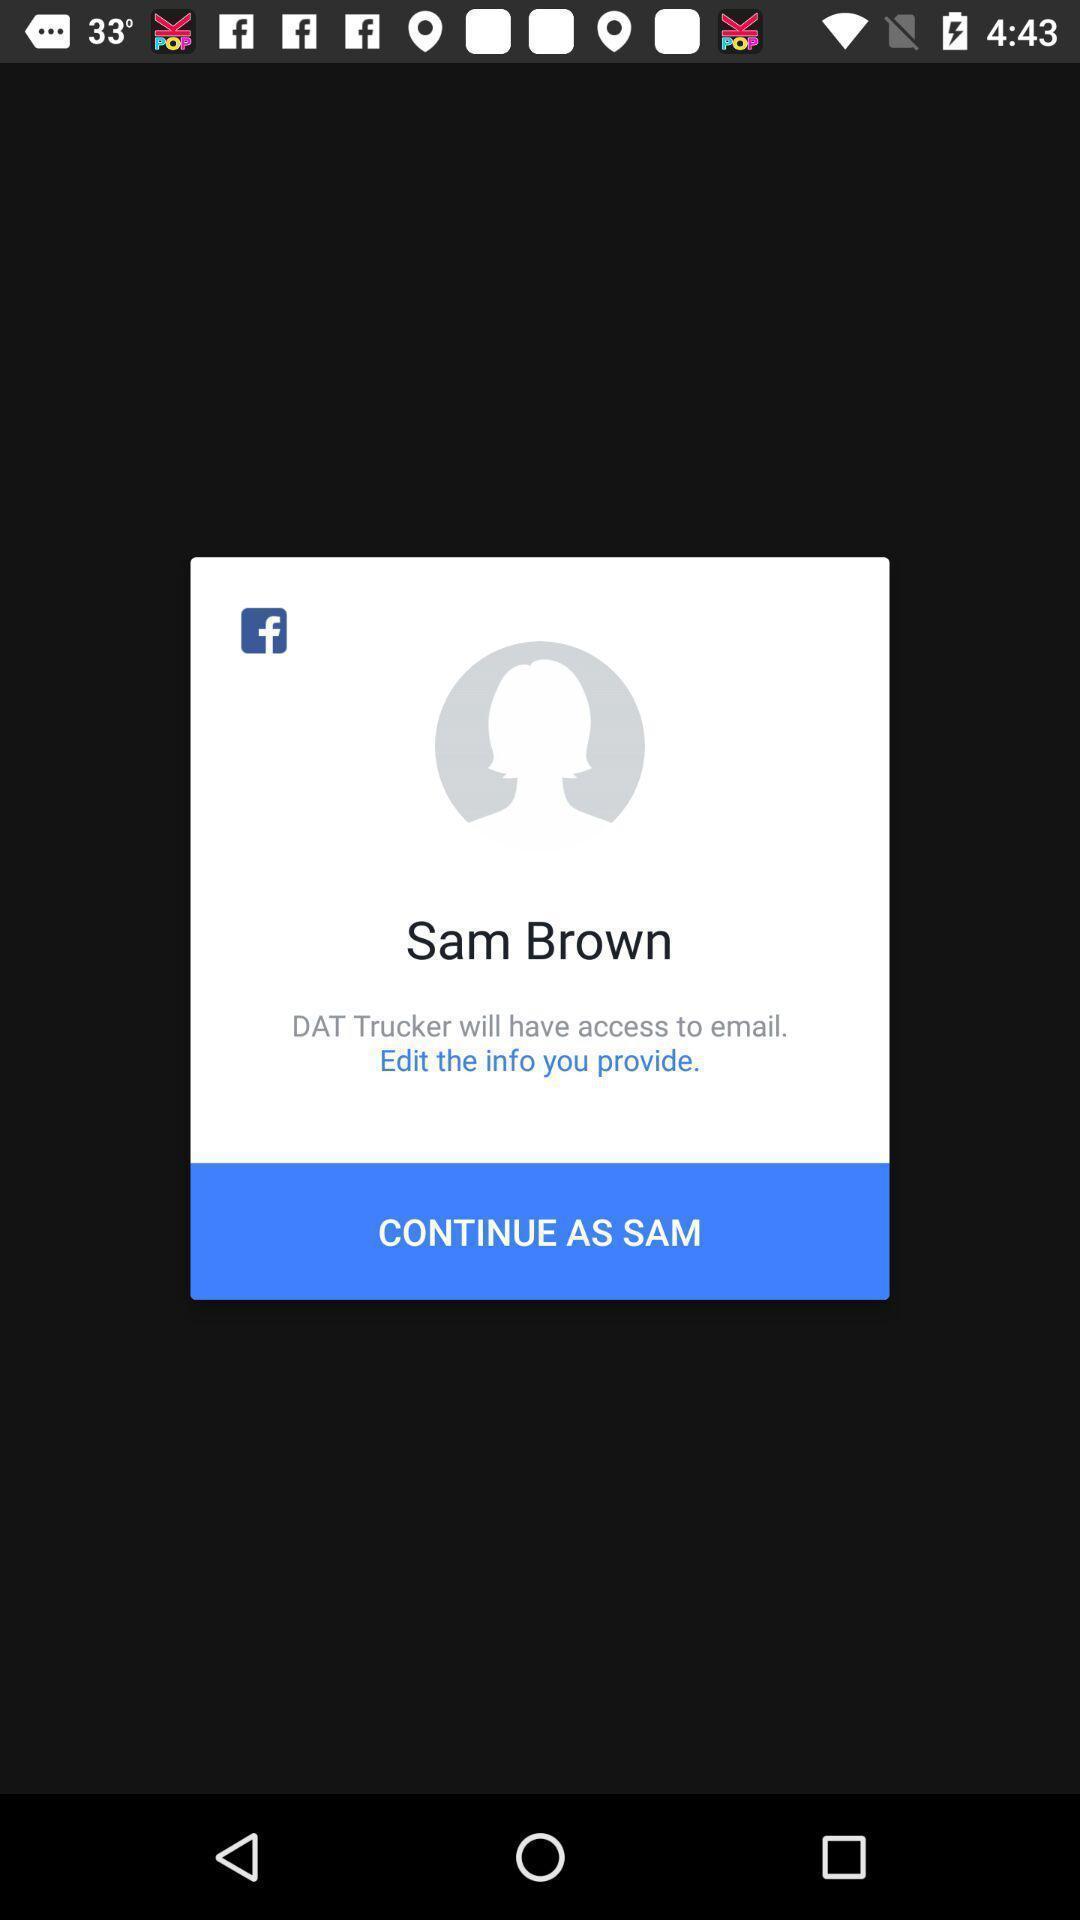Provide a description of this screenshot. Pop-up of a social app on a trucker app. 